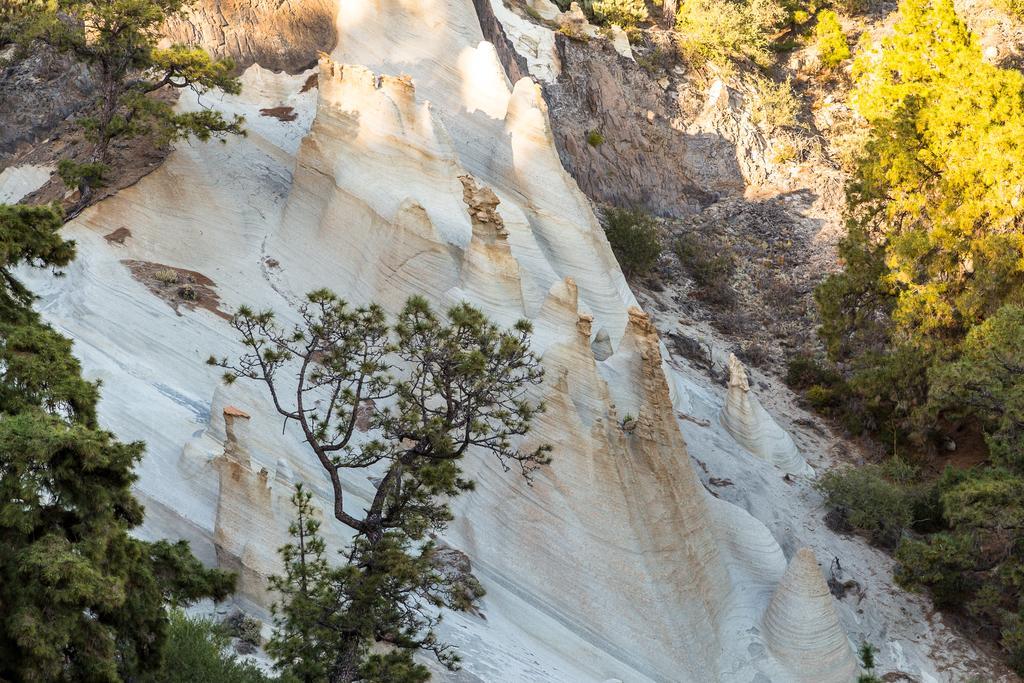Can you describe this image briefly? In this picture we can see outcrop on the surface and trees. 